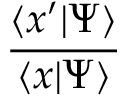Convert formula to latex. <formula><loc_0><loc_0><loc_500><loc_500>\frac { \langle x ^ { \prime } | \Psi \rangle } { \langle x | \Psi \rangle }</formula> 